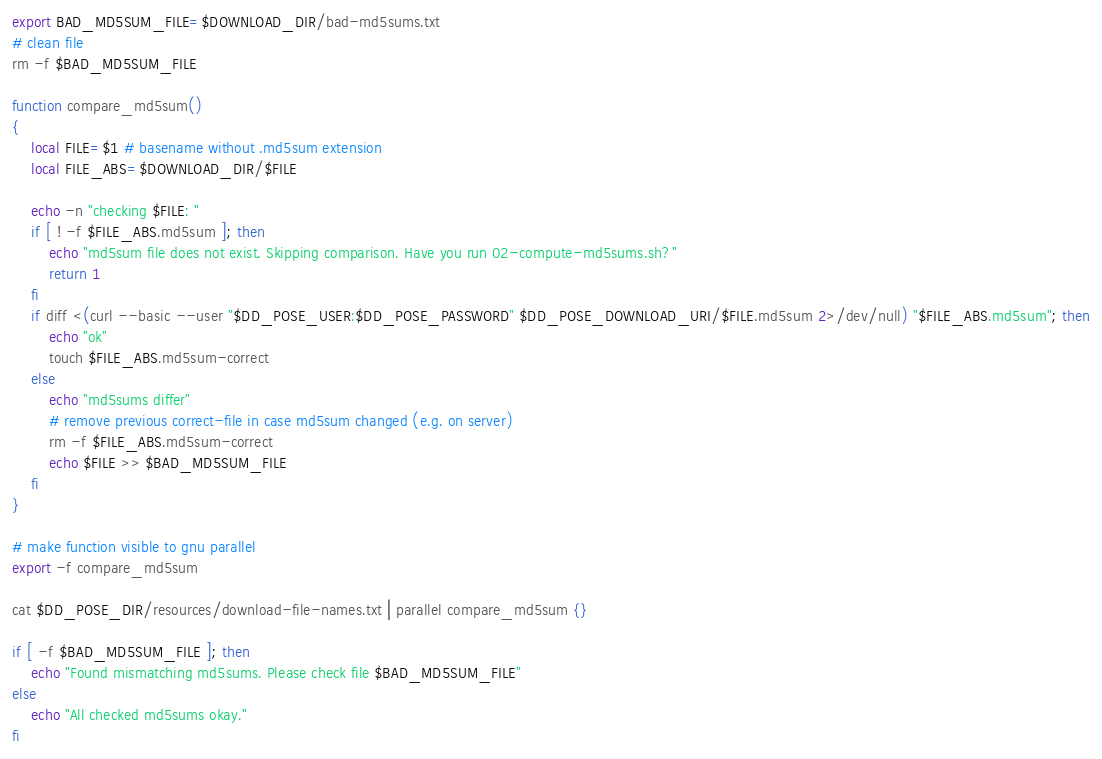<code> <loc_0><loc_0><loc_500><loc_500><_Bash_>export BAD_MD5SUM_FILE=$DOWNLOAD_DIR/bad-md5sums.txt
# clean file
rm -f $BAD_MD5SUM_FILE

function compare_md5sum()
{
    local FILE=$1 # basename without .md5sum extension
    local FILE_ABS=$DOWNLOAD_DIR/$FILE

    echo -n "checking $FILE: "
    if [ ! -f $FILE_ABS.md5sum ]; then
        echo "md5sum file does not exist. Skipping comparison. Have you run 02-compute-md5sums.sh?"
        return 1
    fi
    if diff <(curl --basic --user "$DD_POSE_USER:$DD_POSE_PASSWORD" $DD_POSE_DOWNLOAD_URI/$FILE.md5sum 2>/dev/null) "$FILE_ABS.md5sum"; then
        echo "ok"
        touch $FILE_ABS.md5sum-correct
    else
        echo "md5sums differ"
        # remove previous correct-file in case md5sum changed (e.g. on server)
        rm -f $FILE_ABS.md5sum-correct
        echo $FILE >> $BAD_MD5SUM_FILE
    fi
}

# make function visible to gnu parallel
export -f compare_md5sum

cat $DD_POSE_DIR/resources/download-file-names.txt | parallel compare_md5sum {}

if [ -f $BAD_MD5SUM_FILE ]; then
    echo "Found mismatching md5sums. Please check file $BAD_MD5SUM_FILE"
else
    echo "All checked md5sums okay."
fi
</code> 